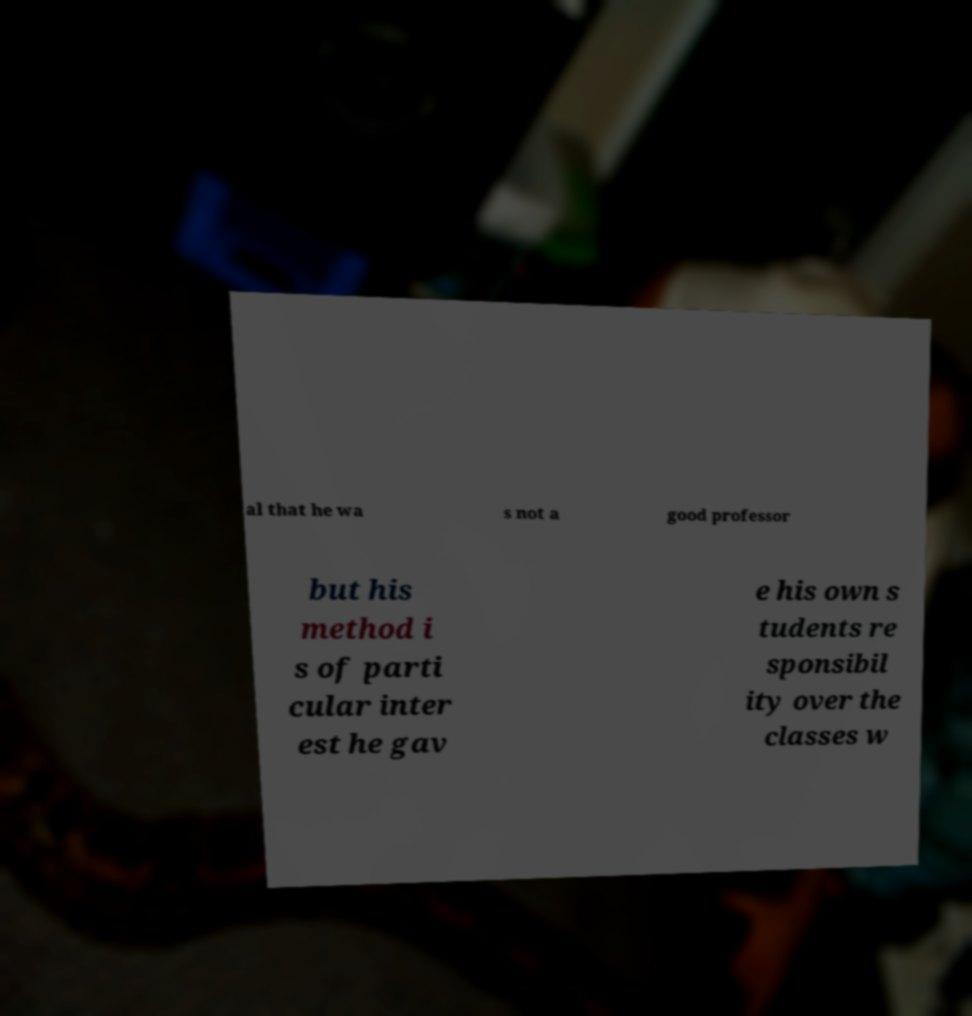Could you extract and type out the text from this image? al that he wa s not a good professor but his method i s of parti cular inter est he gav e his own s tudents re sponsibil ity over the classes w 